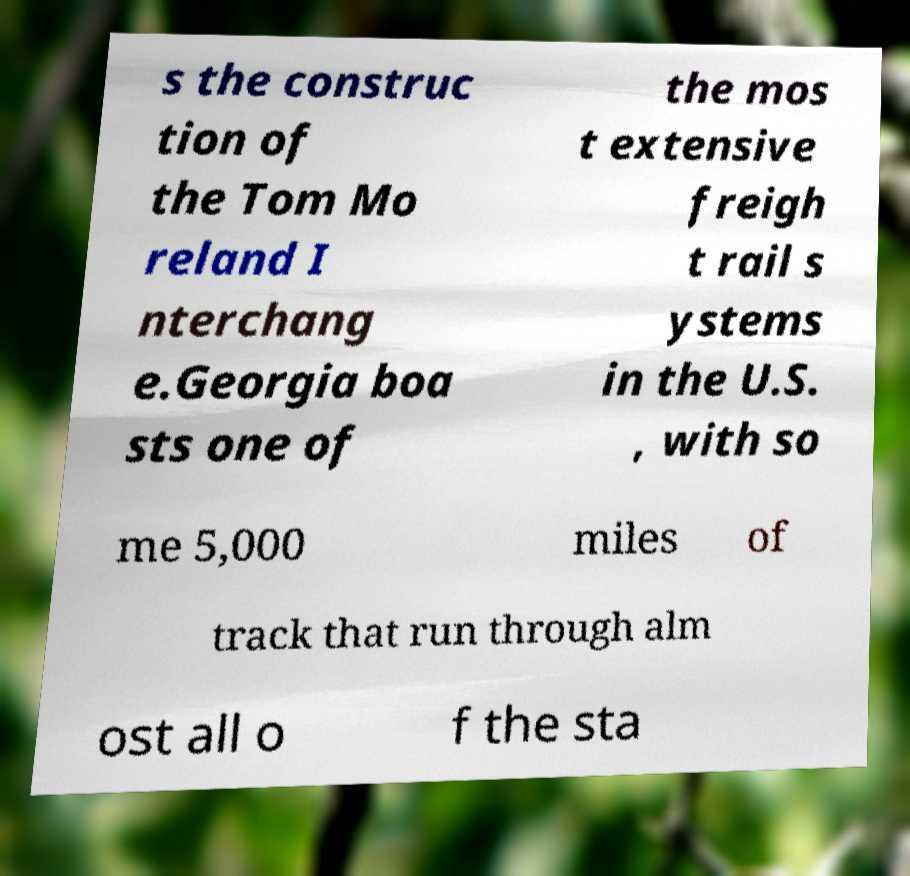Can you accurately transcribe the text from the provided image for me? s the construc tion of the Tom Mo reland I nterchang e.Georgia boa sts one of the mos t extensive freigh t rail s ystems in the U.S. , with so me 5,000 miles of track that run through alm ost all o f the sta 